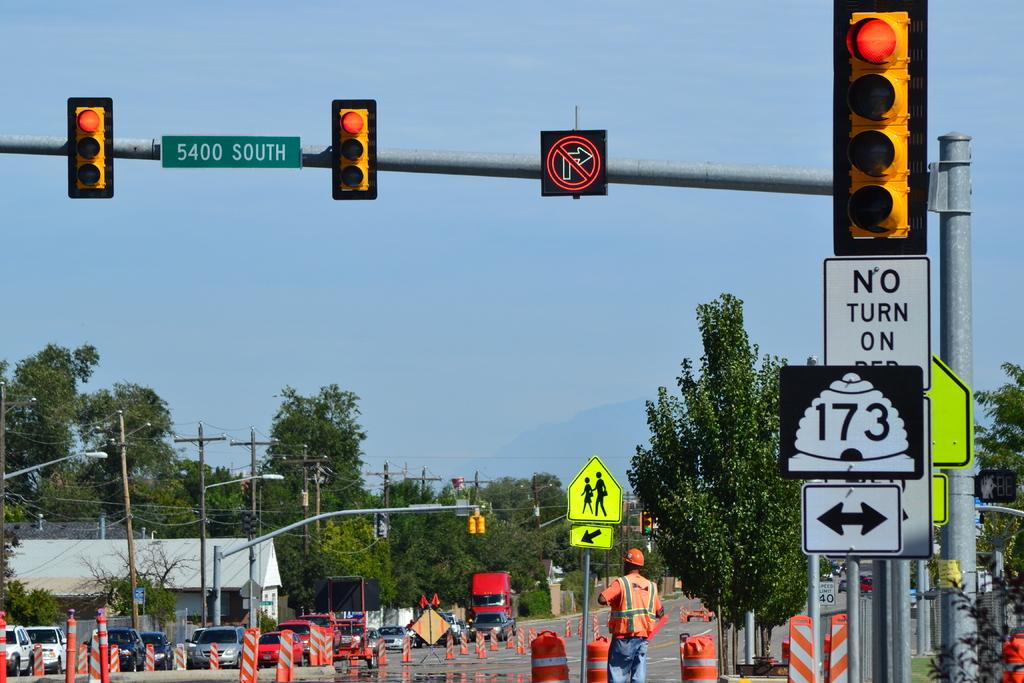<image>
Create a compact narrative representing the image presented. a no turn on red sign that is next to a traffic light 